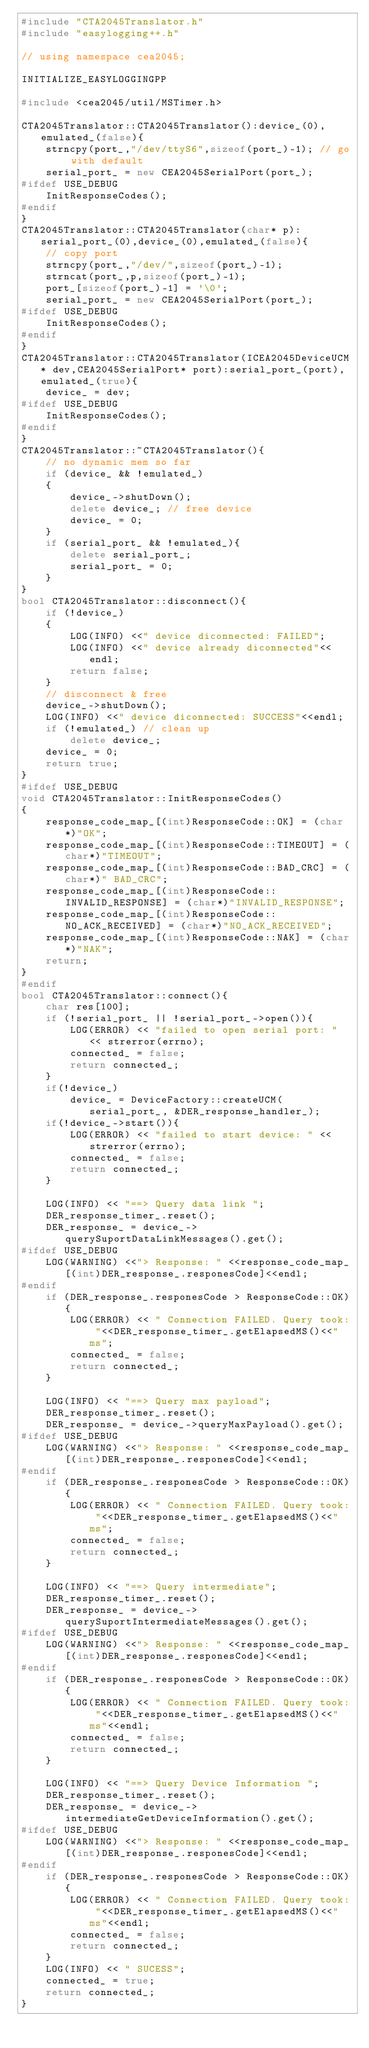Convert code to text. <code><loc_0><loc_0><loc_500><loc_500><_C++_>#include "CTA2045Translator.h"
#include "easylogging++.h"

// using namespace cea2045;

INITIALIZE_EASYLOGGINGPP

#include <cea2045/util/MSTimer.h>

CTA2045Translator::CTA2045Translator():device_(0),emulated_(false){
    strncpy(port_,"/dev/ttyS6",sizeof(port_)-1); // go with default
    serial_port_ = new CEA2045SerialPort(port_);
#ifdef USE_DEBUG
    InitResponseCodes();
#endif
}
CTA2045Translator::CTA2045Translator(char* p):serial_port_(0),device_(0),emulated_(false){
    // copy port
    strncpy(port_,"/dev/",sizeof(port_)-1);
    strncat(port_,p,sizeof(port_)-1);
    port_[sizeof(port_)-1] = '\0';
    serial_port_ = new CEA2045SerialPort(port_);
#ifdef USE_DEBUG
    InitResponseCodes();    
#endif
}
CTA2045Translator::CTA2045Translator(ICEA2045DeviceUCM* dev,CEA2045SerialPort* port):serial_port_(port),emulated_(true){
    device_ = dev;
#ifdef USE_DEBUG
    InitResponseCodes();
#endif
}
CTA2045Translator::~CTA2045Translator(){
    // no dynamic mem so far
    if (device_ && !emulated_)
    {
        device_->shutDown();
        delete device_; // free device
        device_ = 0;
    }
    if (serial_port_ && !emulated_){
        delete serial_port_;
        serial_port_ = 0;
    }
}
bool CTA2045Translator::disconnect(){
    if (!device_)
    {
        LOG(INFO) <<" device diconnected: FAILED";
        LOG(INFO) <<" device already diconnected"<<endl;
        return false;
    }
    // disconnect & free
    device_->shutDown();
    LOG(INFO) <<" device diconnected: SUCCESS"<<endl;
    if (!emulated_) // clean up
        delete device_;
    device_ = 0;
    return true;
}
#ifdef USE_DEBUG
void CTA2045Translator::InitResponseCodes()
{
    response_code_map_[(int)ResponseCode::OK] = (char*)"OK";
    response_code_map_[(int)ResponseCode::TIMEOUT] = (char*)"TIMEOUT";
    response_code_map_[(int)ResponseCode::BAD_CRC] = (char*)" BAD_CRC";
    response_code_map_[(int)ResponseCode::INVALID_RESPONSE] = (char*)"INVALID_RESPONSE";
    response_code_map_[(int)ResponseCode::NO_ACK_RECEIVED] = (char*)"NO_ACK_RECEIVED";
    response_code_map_[(int)ResponseCode::NAK] = (char*)"NAK";
    return;
}
#endif
bool CTA2045Translator::connect(){
    char res[100];
	if (!serial_port_ || !serial_port_->open()){
		LOG(ERROR) << "failed to open serial port: " << strerror(errno);
		connected_ = false;
        return connected_;
	}
    if(!device_)
	    device_ = DeviceFactory::createUCM(serial_port_, &DER_response_handler_);
	if(!device_->start()){
        LOG(ERROR) << "failed to start device: " << strerror(errno);
		connected_ = false;
        return connected_;
    }  

	LOG(INFO) << "==> Query data link ";
	DER_response_timer_.reset();
	DER_response_ = device_->querySuportDataLinkMessages().get();
#ifdef USE_DEBUG
    LOG(WARNING) <<"> Response: " <<response_code_map_[(int)DER_response_.responesCode]<<endl;
#endif
    if (DER_response_.responesCode > ResponseCode::OK){
        LOG(ERROR) << " Connection FAILED. Query took: "<<DER_response_timer_.getElapsedMS()<<" ms";
        connected_ = false;
        return connected_;
    }

	LOG(INFO) << "==> Query max payload";
	DER_response_timer_.reset();
	DER_response_ = device_->queryMaxPayload().get();
#ifdef USE_DEBUG
    LOG(WARNING) <<"> Response: " <<response_code_map_[(int)DER_response_.responesCode]<<endl;
#endif
    if (DER_response_.responesCode > ResponseCode::OK){
        LOG(ERROR) << " Connection FAILED. Query took: "<<DER_response_timer_.getElapsedMS()<<" ms";
        connected_ = false;
        return connected_;
    }

	LOG(INFO) << "==> Query intermediate";
	DER_response_timer_.reset();
	DER_response_ = device_->querySuportIntermediateMessages().get();
#ifdef USE_DEBUG
    LOG(WARNING) <<"> Response: " <<response_code_map_[(int)DER_response_.responesCode]<<endl;
#endif
    if (DER_response_.responesCode > ResponseCode::OK){
        LOG(ERROR) << " Connection FAILED. Query took: "<<DER_response_timer_.getElapsedMS()<<" ms"<<endl;
        connected_ = false;
        return connected_;
    }

	LOG(INFO) << "==> Query Device Information ";
	DER_response_timer_.reset();
	DER_response_ = device_->intermediateGetDeviceInformation().get();
#ifdef USE_DEBUG
    LOG(WARNING) <<"> Response: " <<response_code_map_[(int)DER_response_.responesCode]<<endl;
#endif
    if (DER_response_.responesCode > ResponseCode::OK){
        LOG(ERROR) << " Connection FAILED. Query took: "<<DER_response_timer_.getElapsedMS()<<" ms"<<endl;
        connected_ = false;
        return connected_;
    }
    LOG(INFO) << " SUCESS";
    connected_ = true;
    return connected_;
}</code> 